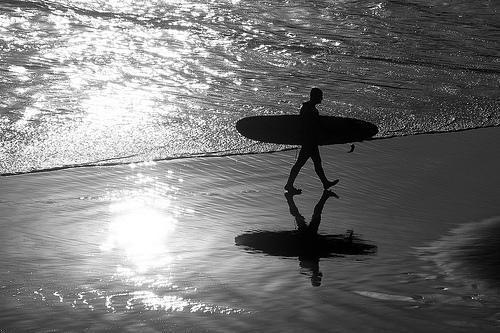How many people are in the picture?
Give a very brief answer. 1. How many feet are in this picture?
Give a very brief answer. 2. 